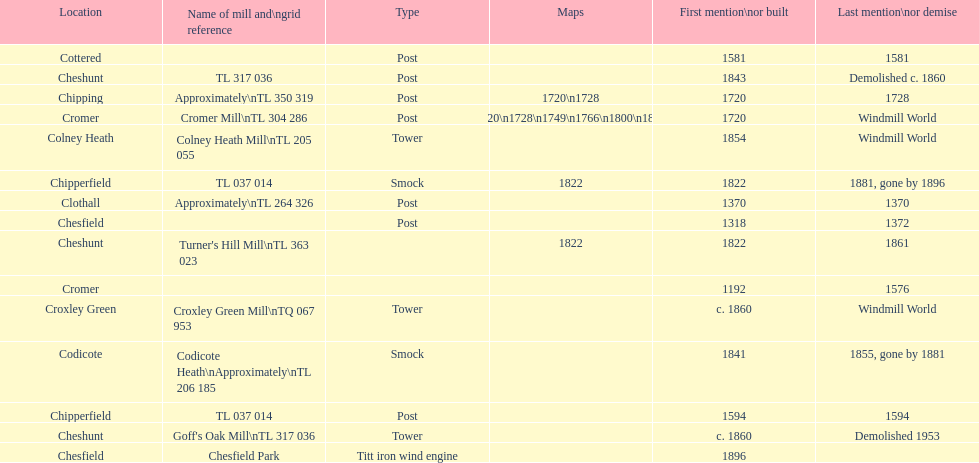How many locations have or had at least 2 windmills? 4. 